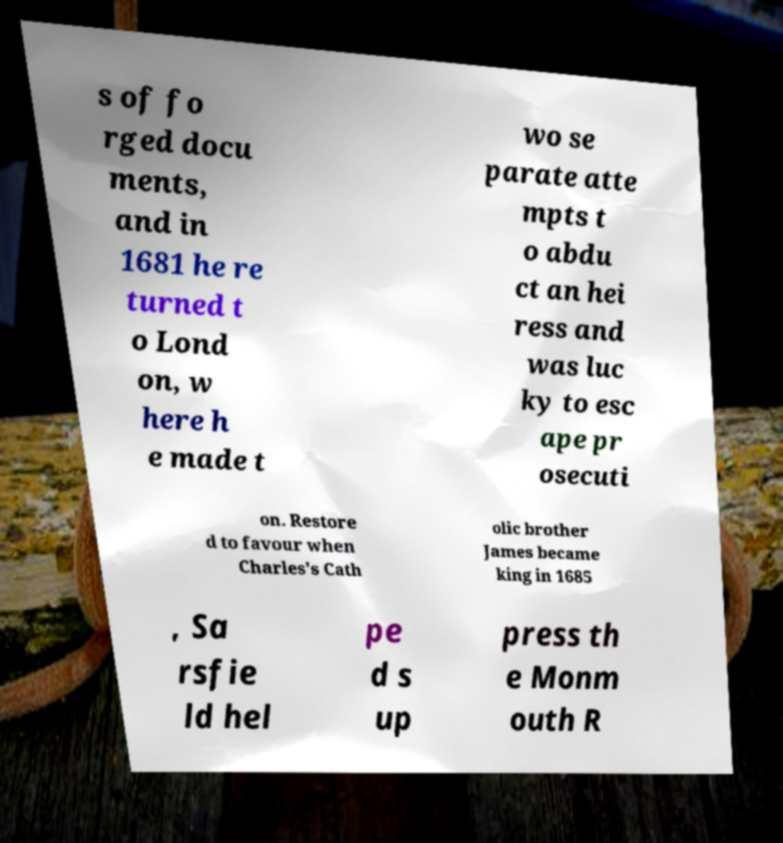Can you accurately transcribe the text from the provided image for me? s of fo rged docu ments, and in 1681 he re turned t o Lond on, w here h e made t wo se parate atte mpts t o abdu ct an hei ress and was luc ky to esc ape pr osecuti on. Restore d to favour when Charles's Cath olic brother James became king in 1685 , Sa rsfie ld hel pe d s up press th e Monm outh R 